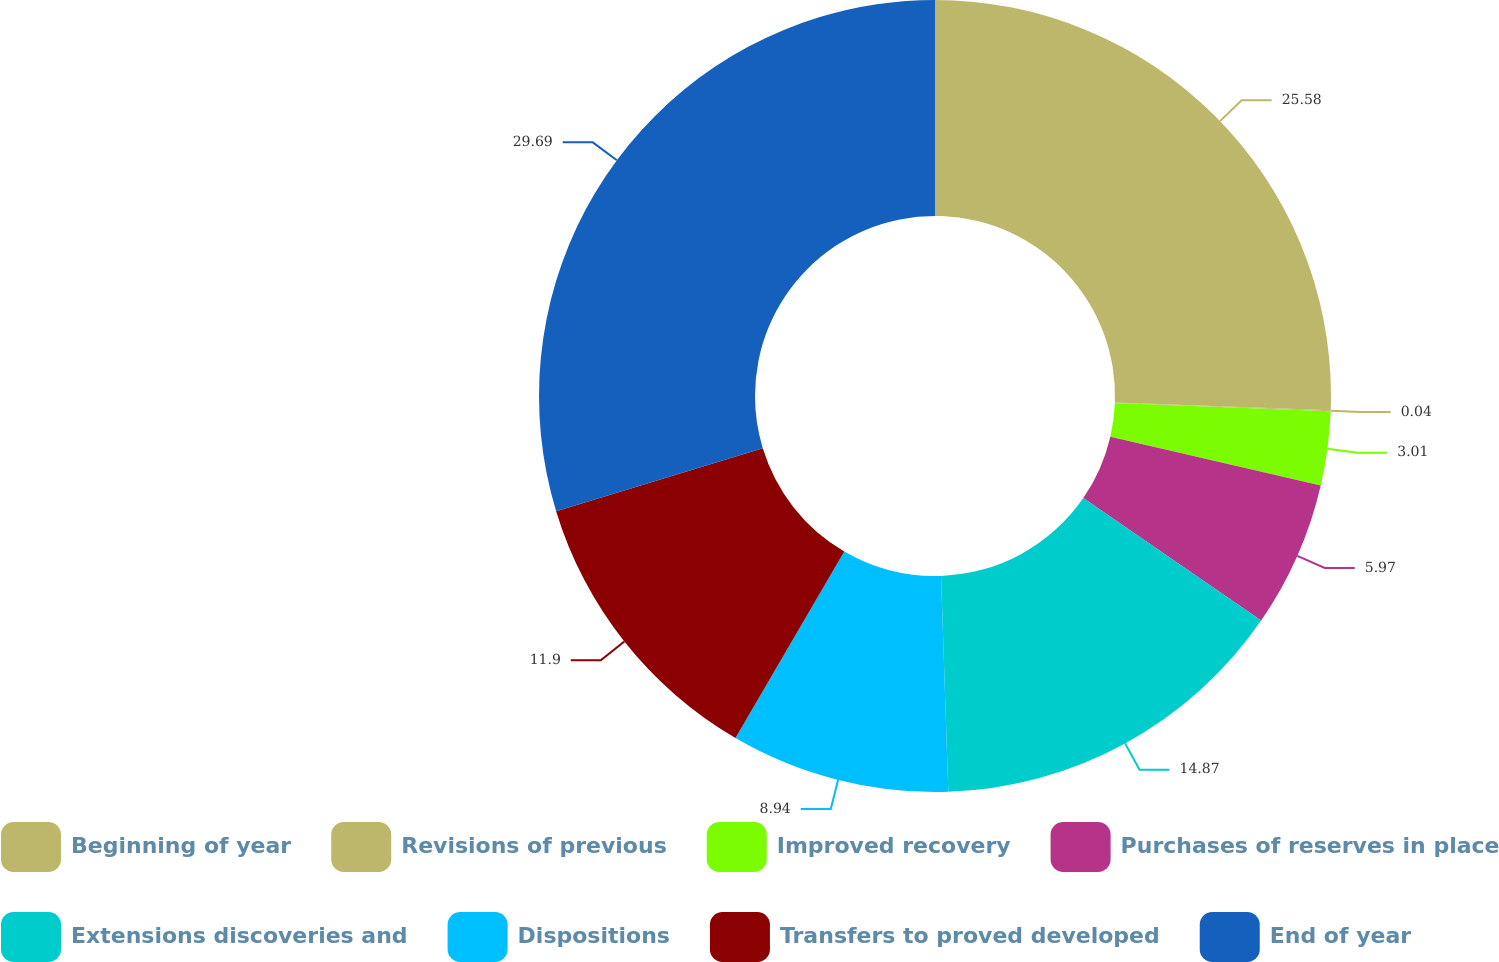<chart> <loc_0><loc_0><loc_500><loc_500><pie_chart><fcel>Beginning of year<fcel>Revisions of previous<fcel>Improved recovery<fcel>Purchases of reserves in place<fcel>Extensions discoveries and<fcel>Dispositions<fcel>Transfers to proved developed<fcel>End of year<nl><fcel>25.58%<fcel>0.04%<fcel>3.01%<fcel>5.97%<fcel>14.87%<fcel>8.94%<fcel>11.9%<fcel>29.7%<nl></chart> 